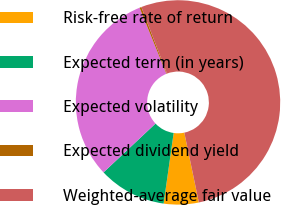<chart> <loc_0><loc_0><loc_500><loc_500><pie_chart><fcel>Risk-free rate of return<fcel>Expected term (in years)<fcel>Expected volatility<fcel>Expected dividend yield<fcel>Weighted-average fair value<nl><fcel>5.52%<fcel>10.75%<fcel>30.86%<fcel>0.3%<fcel>52.57%<nl></chart> 